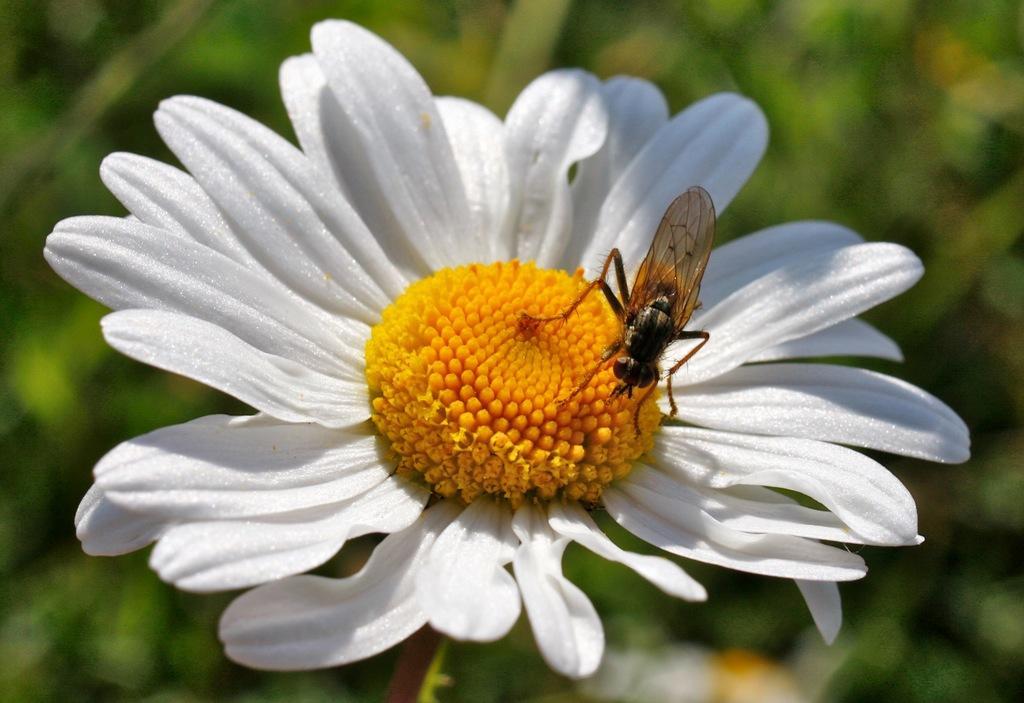Could you give a brief overview of what you see in this image? In the image we can see a flower, on the flower there is a insect. Background of the image is blur. 